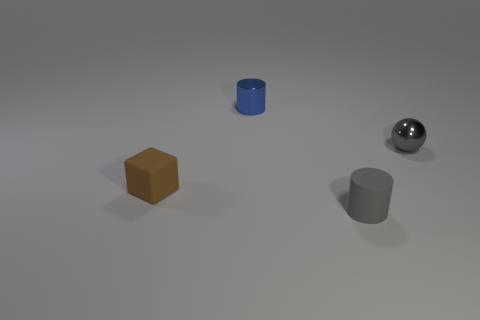Add 4 rubber things. How many objects exist? 8 Subtract all blocks. How many objects are left? 3 Subtract 0 brown spheres. How many objects are left? 4 Subtract all tiny blocks. Subtract all shiny balls. How many objects are left? 2 Add 2 rubber objects. How many rubber objects are left? 4 Add 2 red metallic cubes. How many red metallic cubes exist? 2 